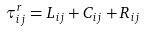<formula> <loc_0><loc_0><loc_500><loc_500>\tau _ { i j } ^ { r } = L _ { i j } + C _ { i j } + R _ { i j }</formula> 